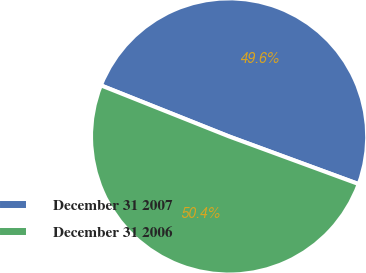Convert chart to OTSL. <chart><loc_0><loc_0><loc_500><loc_500><pie_chart><fcel>December 31 2007<fcel>December 31 2006<nl><fcel>49.57%<fcel>50.43%<nl></chart> 